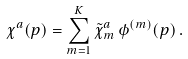<formula> <loc_0><loc_0><loc_500><loc_500>\chi ^ { a } ( p ) = \sum _ { m = 1 } ^ { K } \tilde { \chi } ^ { a } _ { m } \, \phi ^ { ( m ) } ( p ) \, .</formula> 